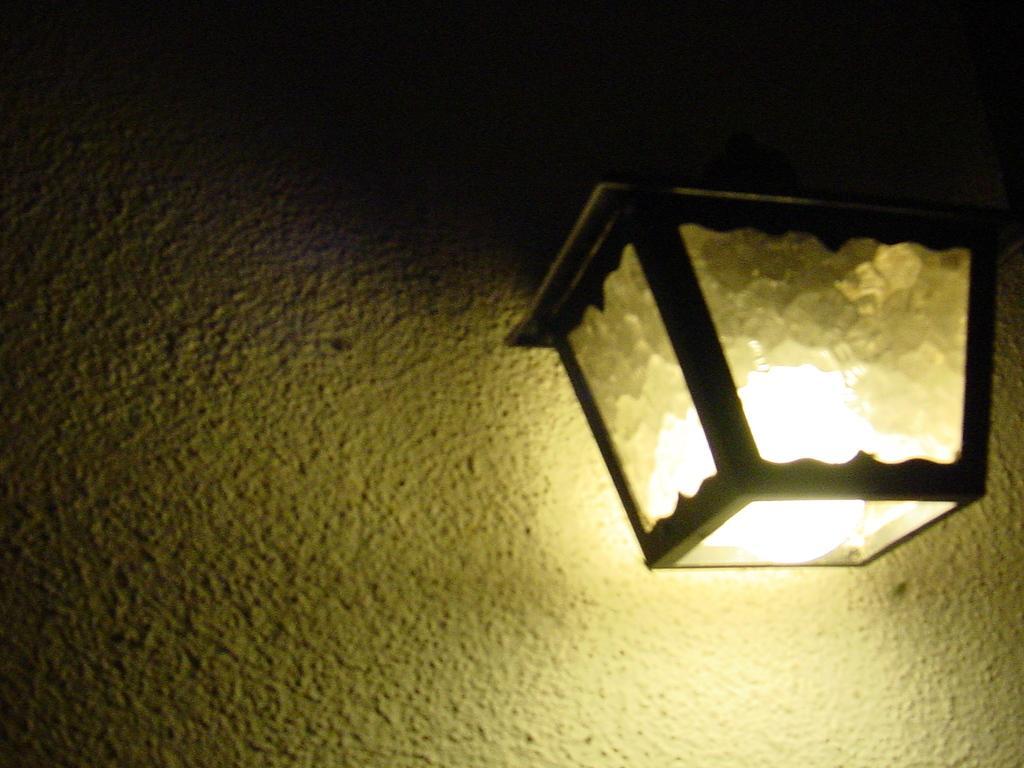Could you give a brief overview of what you see in this image? This is an image clicked in the dark. On the right side I can see a Lantern. At the back of it I can see the wall. 